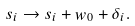<formula> <loc_0><loc_0><loc_500><loc_500>s _ { i } \rightarrow s _ { i } + w _ { 0 } + \delta _ { i } .</formula> 